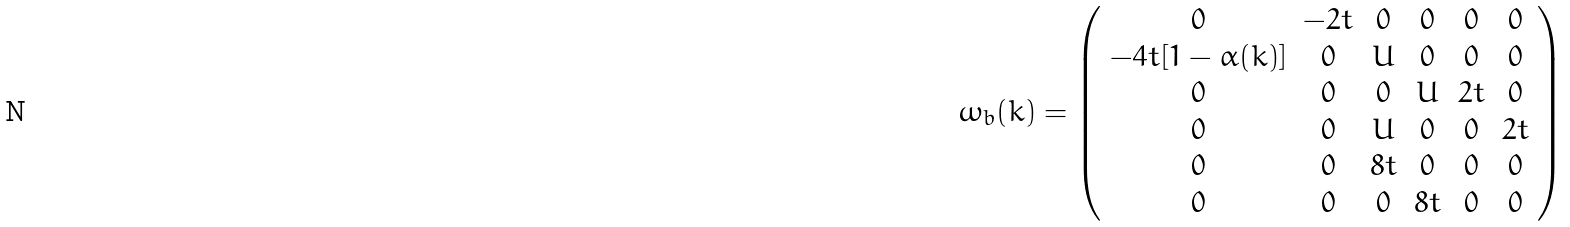<formula> <loc_0><loc_0><loc_500><loc_500>\omega _ { b } ( k ) = \left ( \begin{array} { c c c c c c } 0 & - 2 t & 0 & 0 & 0 & 0 \\ - 4 t [ 1 - \alpha ( k ) ] & 0 & U & 0 & 0 & 0 \\ 0 & 0 & 0 & U & 2 t & 0 \\ 0 & 0 & U & 0 & 0 & 2 t \\ 0 & 0 & 8 t & 0 & 0 & 0 \\ 0 & 0 & 0 & 8 t & 0 & 0 \end{array} \right )</formula> 